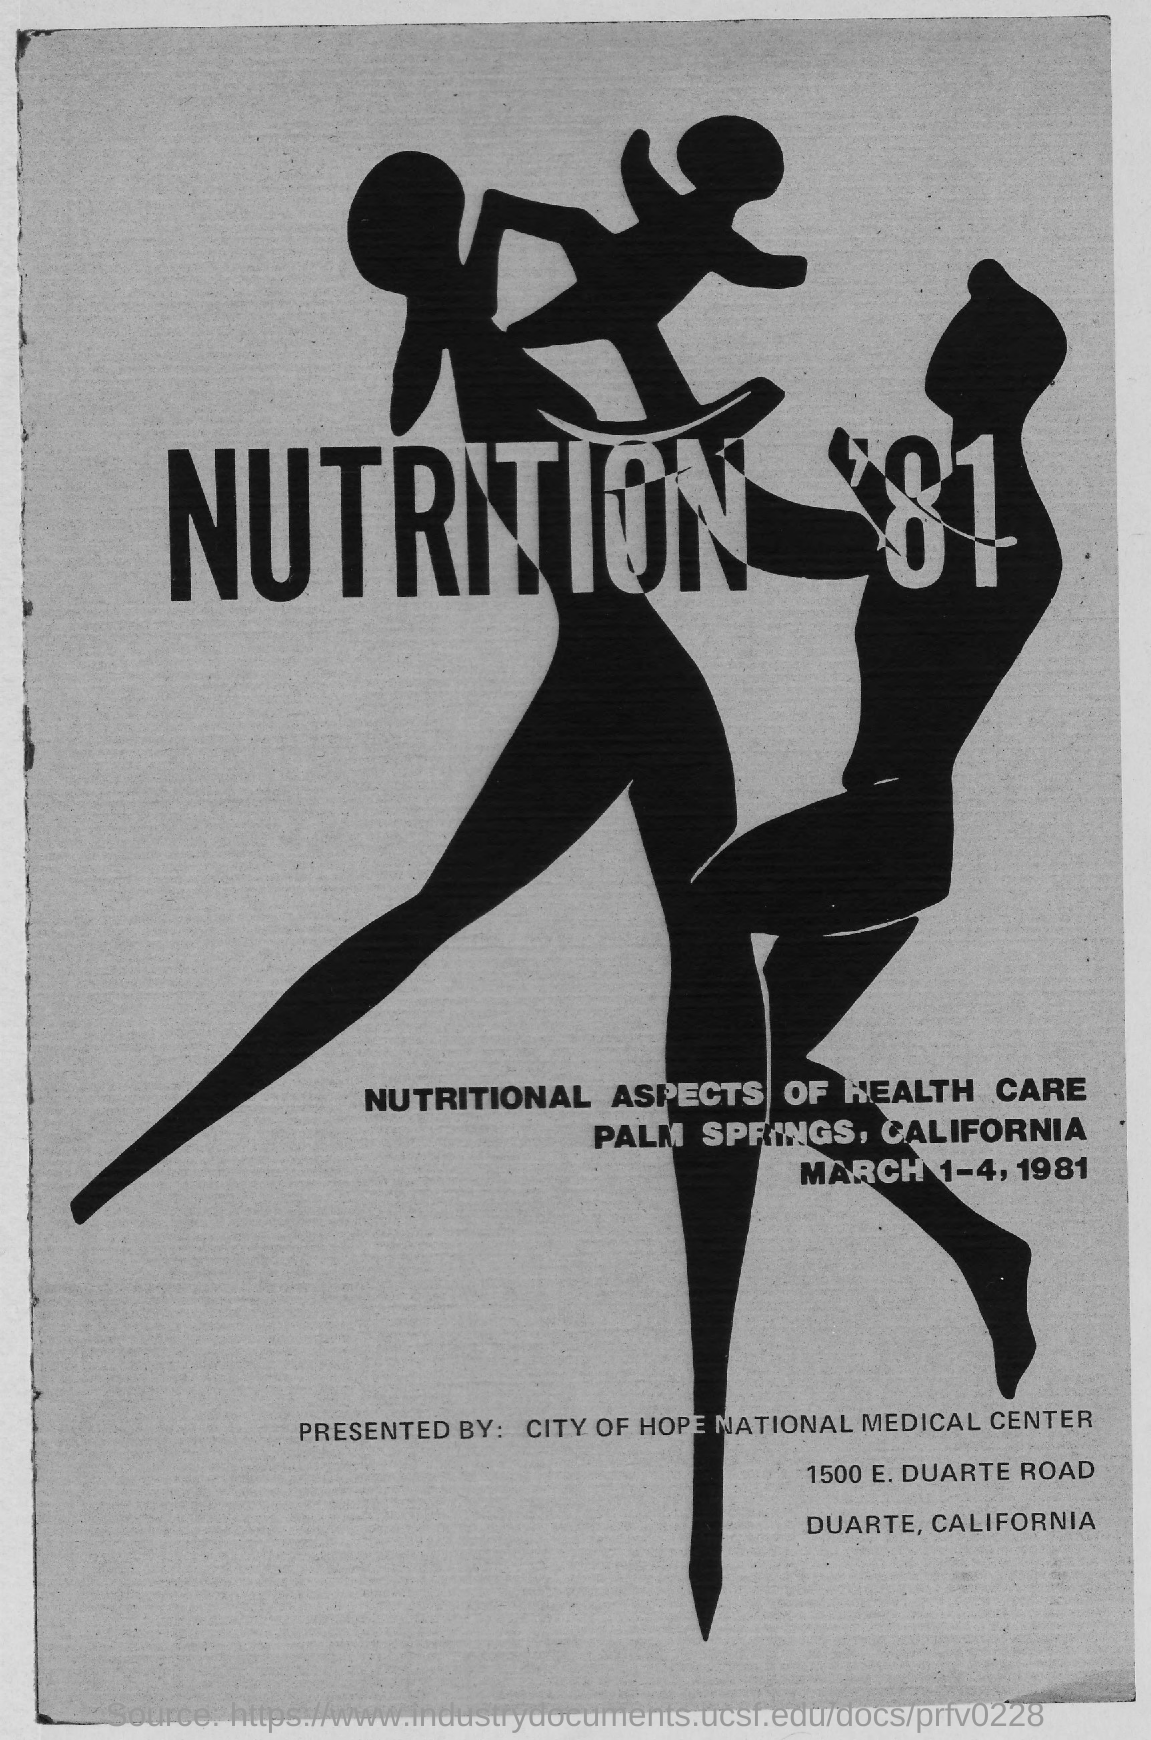When was the event 'NUTRITION '81?
Your response must be concise. MARCH 1-4, 1981. Where was the event 'NUTRITION '81 held?
Offer a very short reply. PALM SPRINGS, CALIFORNIA. Who presented the event 'NUTRITION '81?
Provide a short and direct response. CITY OF HOPE NATIONAL MEDICAL CENTER. 